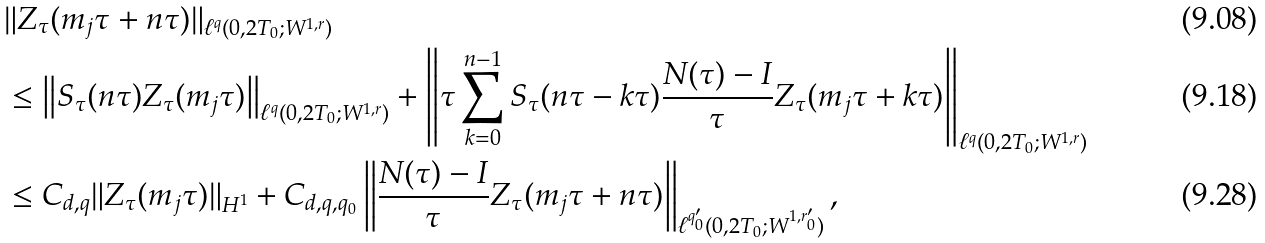<formula> <loc_0><loc_0><loc_500><loc_500>& \| Z _ { \tau } ( m _ { j } \tau + n \tau ) \| _ { \ell ^ { q } ( 0 , 2 T _ { 0 } ; W ^ { 1 , r } ) } \\ & \leq \left \| S _ { \tau } ( n \tau ) Z _ { \tau } ( m _ { j } \tau ) \right \| _ { \ell ^ { q } ( 0 , 2 T _ { 0 } ; W ^ { 1 , r } ) } + \left \| \tau \sum _ { k = 0 } ^ { n - 1 } S _ { \tau } ( n \tau - k \tau ) \frac { N ( \tau ) - I } { \tau } Z _ { \tau } ( m _ { j } \tau + k \tau ) \right \| _ { \ell ^ { q } ( 0 , 2 T _ { 0 } ; W ^ { 1 , r } ) } \\ & \leq C _ { d , q } \| Z _ { \tau } ( m _ { j } \tau ) \| _ { { H } ^ { 1 } } + C _ { d , q , q _ { 0 } } \left \| \frac { N ( \tau ) - I } { \tau } Z _ { \tau } ( m _ { j } \tau + n \tau ) \right \| _ { \ell ^ { q _ { 0 } ^ { \prime } } ( 0 , 2 T _ { 0 } ; W ^ { 1 , r _ { 0 } ^ { \prime } } ) } ,</formula> 